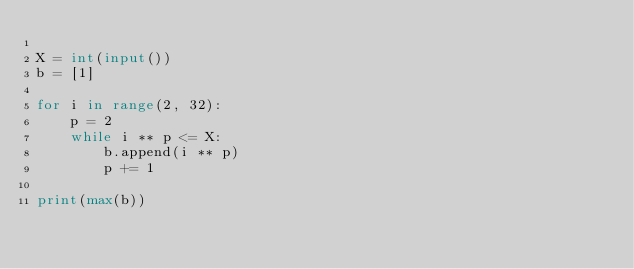<code> <loc_0><loc_0><loc_500><loc_500><_Python_>
X = int(input())
b = [1]

for i in range(2, 32):
    p = 2
    while i ** p <= X:
        b.append(i ** p)
        p += 1

print(max(b))</code> 